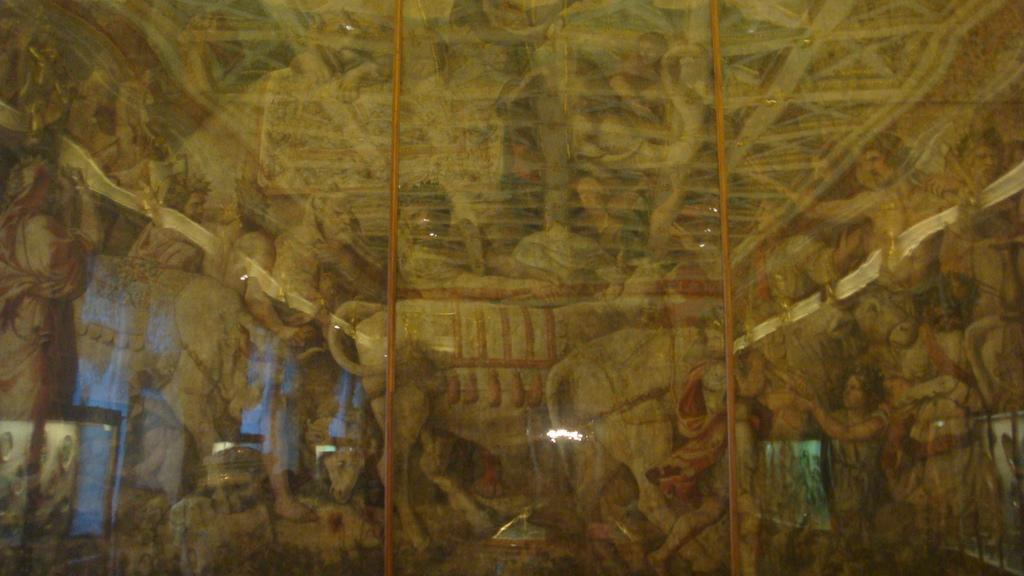What is the main subject of the image? The main subject of the image is a painting. What is depicted in the painting? The painting depicts a group of persons and some animals. What type of club is being used by the bee in the image? There is no bee present in the image, and therefore no club can be associated with it. 